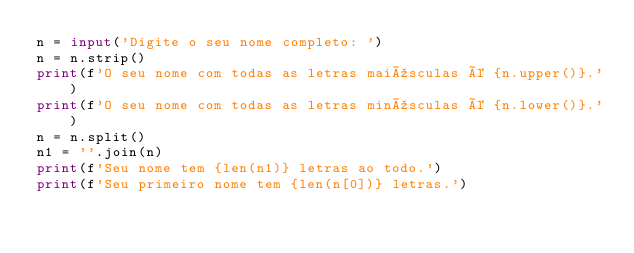<code> <loc_0><loc_0><loc_500><loc_500><_Python_>n = input('Digite o seu nome completo: ')
n = n.strip()
print(f'O seu nome com todas as letras maiúsculas é {n.upper()}.')
print(f'O seu nome com todas as letras minúsculas é {n.lower()}.')
n = n.split()
n1 = ''.join(n)
print(f'Seu nome tem {len(n1)} letras ao todo.')
print(f'Seu primeiro nome tem {len(n[0])} letras.')
</code> 